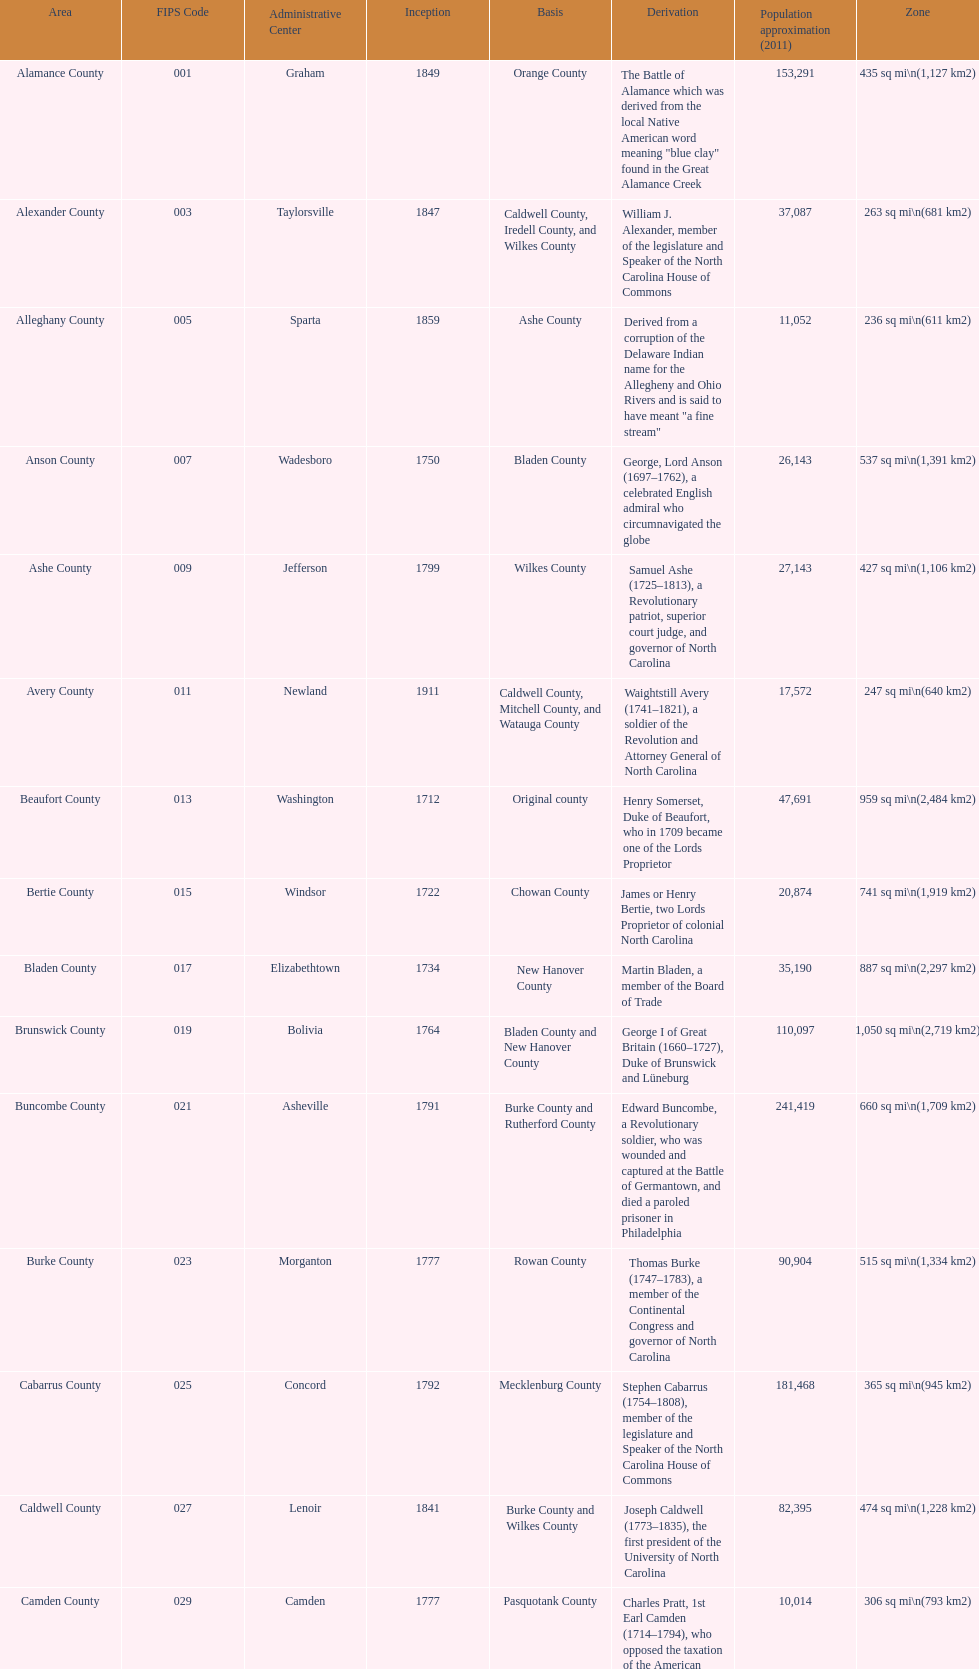Which county covers the most area? Dare County. 